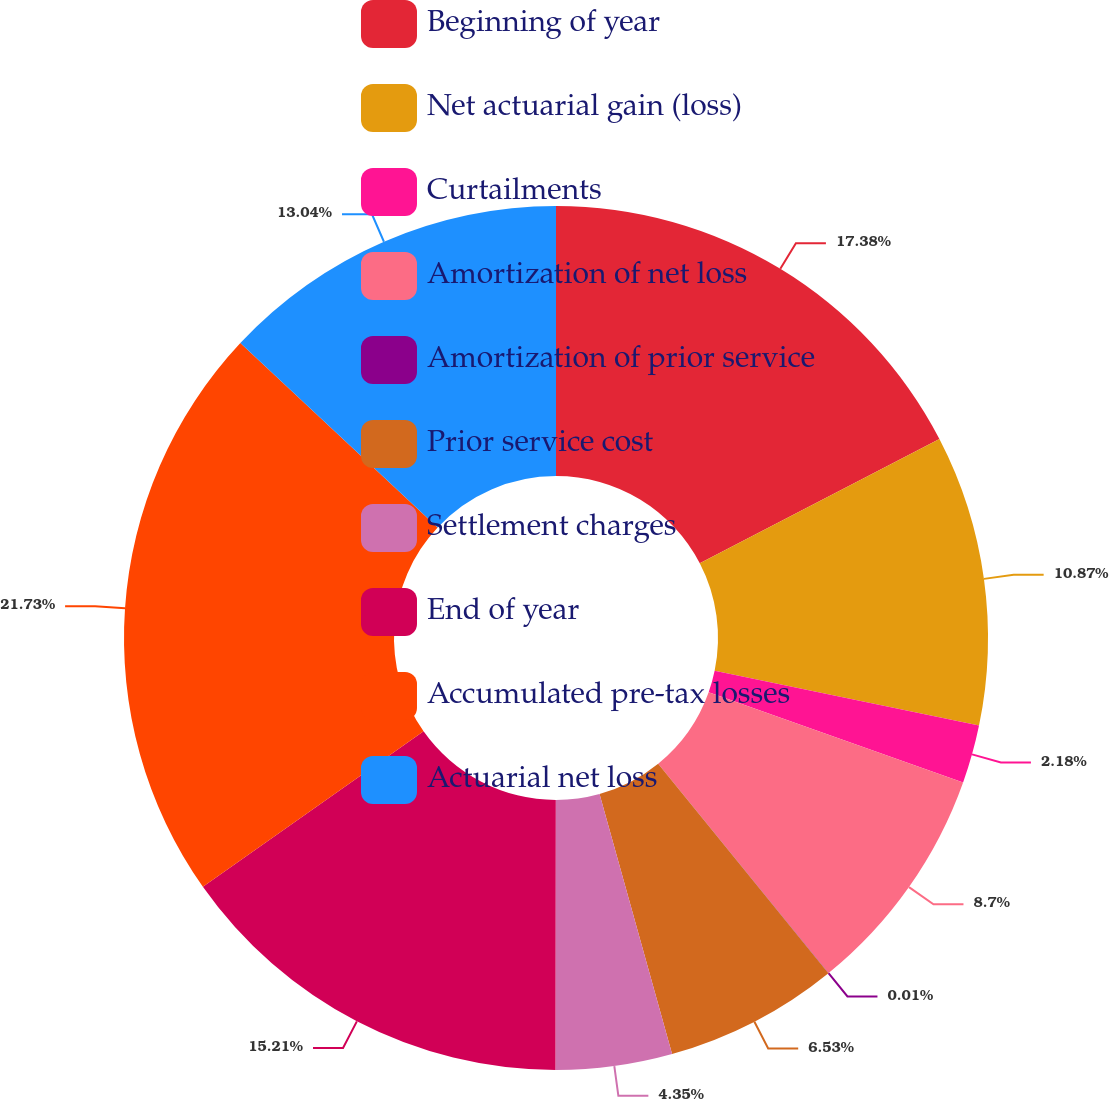<chart> <loc_0><loc_0><loc_500><loc_500><pie_chart><fcel>Beginning of year<fcel>Net actuarial gain (loss)<fcel>Curtailments<fcel>Amortization of net loss<fcel>Amortization of prior service<fcel>Prior service cost<fcel>Settlement charges<fcel>End of year<fcel>Accumulated pre-tax losses<fcel>Actuarial net loss<nl><fcel>17.38%<fcel>10.87%<fcel>2.18%<fcel>8.7%<fcel>0.01%<fcel>6.53%<fcel>4.35%<fcel>15.21%<fcel>21.73%<fcel>13.04%<nl></chart> 